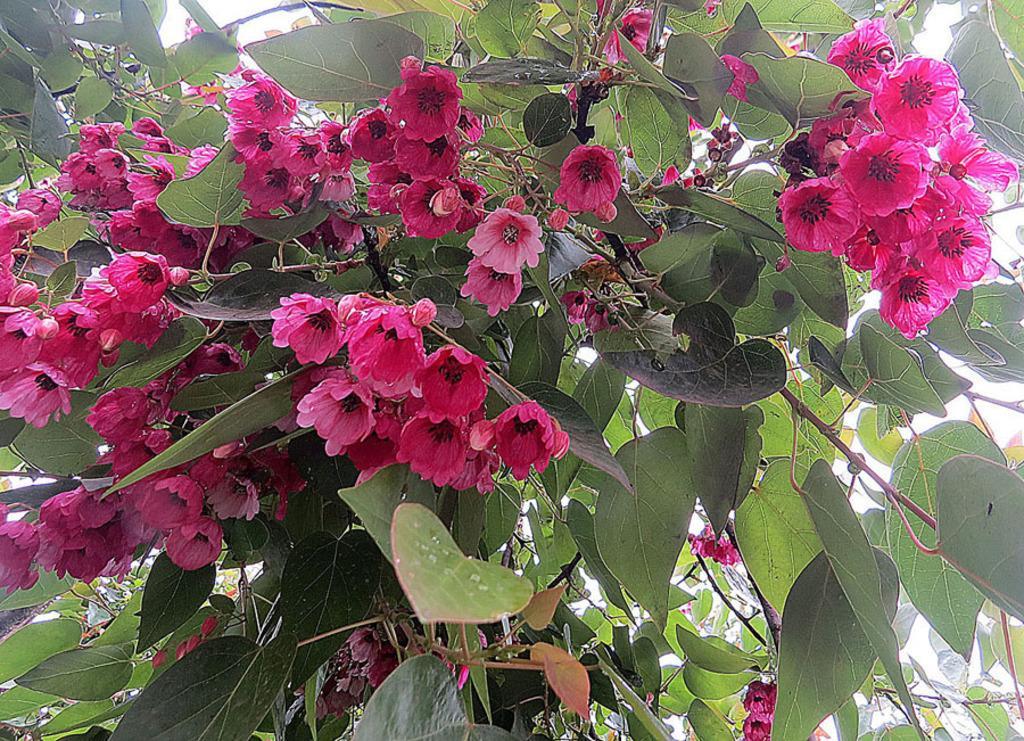Can you describe this image briefly? In the image in the center, we can see trees and flowers, which are pink in color. 